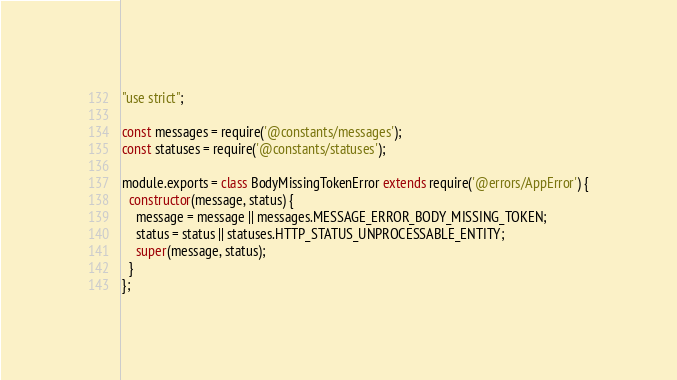<code> <loc_0><loc_0><loc_500><loc_500><_JavaScript_>"use strict";

const messages = require('@constants/messages');
const statuses = require('@constants/statuses');

module.exports = class BodyMissingTokenError extends require('@errors/AppError') {
  constructor(message, status) {
    message = message || messages.MESSAGE_ERROR_BODY_MISSING_TOKEN;
    status = status || statuses.HTTP_STATUS_UNPROCESSABLE_ENTITY;
    super(message, status);
  }
};</code> 